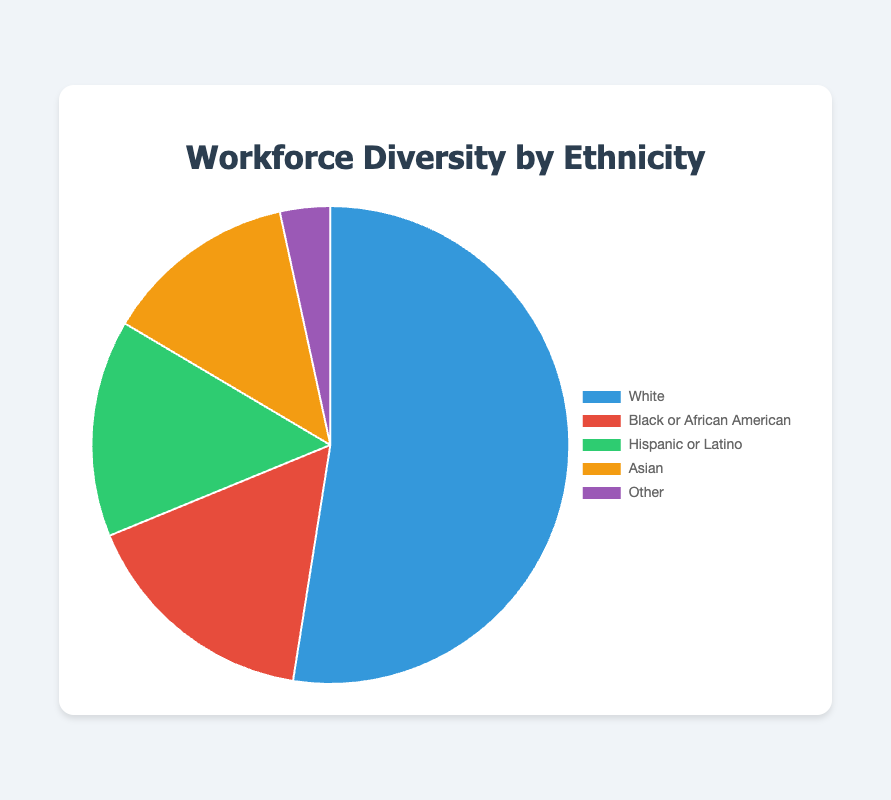What percentage of the workforce does the largest ethnic group represent? The largest ethnic group is White, and the corresponding percentage is 52.5% according to the chart.
Answer: 52.5% Which ethnic group has the smallest representation in the workforce? The chart shows the data for "Other" ethnic group as 3.4%, which is the smallest among all groups.
Answer: Other How do the combined percentages of Black or African American and Hispanic or Latino compare to the percentage of White? First, sum the percentages of Black or African American (16.3%) and Hispanic or Latino (14.7%): 16.3 + 14.7 = 31.0%. Next, compare this with the percentage of White (52.5%). 31.0% is less than 52.5%.
Answer: Less than Which group has a higher representation: Asian or Hispanic or Latino? The chart shows the percentage for Asian is 13.1% and for Hispanic or Latino is 14.7%. Therefore, Hispanic or Latino has a higher representation.
Answer: Hispanic or Latino If we combine the percentages of Asian and Other, what would be the resulting percentage? Sum the percentages of Asian (13.1%) and Other (3.4%): 13.1 + 3.4 = 16.5%.
Answer: 16.5% What's the difference in percentage between the workforce representation of White and Black or African American? Subtract the percentage of Black or African American (16.3%) from White (52.5%): 52.5 - 16.3 = 36.2%.
Answer: 36.2% If another ethnic group with a 5% representation were to be added to this pie chart, what would be the new percentage representation for the White group? The current total is 100%. With an additional 5%, the new total becomes 105%. The White group's new percentage is calculated as (52.5 / 105) * 100 ≈ 50%.
Answer: 50% Is the percentage of the Asian group greater or less than the percentage of the Hispanic or Latino group? The chart shows the percentage for Asian is 13.1% and for Hispanic or Latino is 14.7%, so the percentage for Asian is less.
Answer: Less 